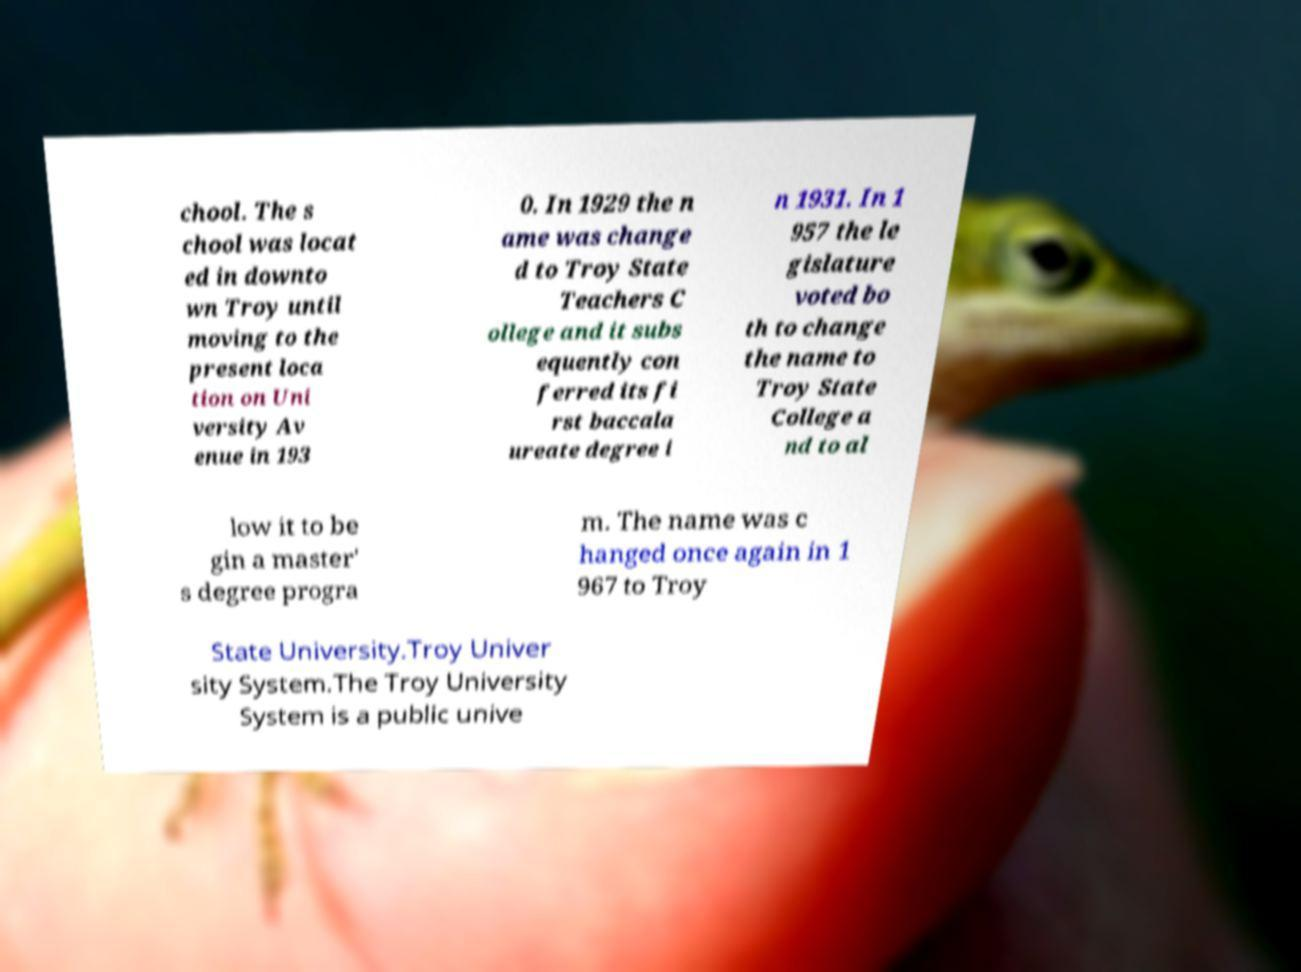Could you assist in decoding the text presented in this image and type it out clearly? chool. The s chool was locat ed in downto wn Troy until moving to the present loca tion on Uni versity Av enue in 193 0. In 1929 the n ame was change d to Troy State Teachers C ollege and it subs equently con ferred its fi rst baccala ureate degree i n 1931. In 1 957 the le gislature voted bo th to change the name to Troy State College a nd to al low it to be gin a master' s degree progra m. The name was c hanged once again in 1 967 to Troy State University.Troy Univer sity System.The Troy University System is a public unive 